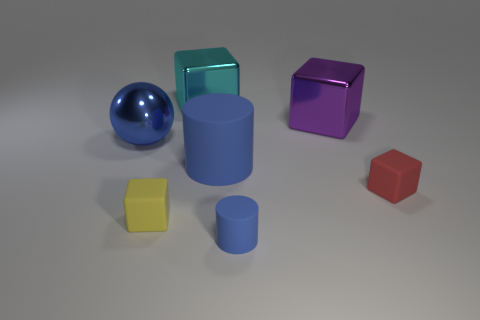How many other things are there of the same color as the big matte cylinder?
Ensure brevity in your answer.  2. Is the color of the shiny ball the same as the cylinder that is in front of the big rubber object?
Make the answer very short. Yes. What number of blue things are big shiny balls or big matte things?
Your response must be concise. 2. Are there an equal number of small blue cylinders right of the red object and tiny brown rubber cubes?
Keep it short and to the point. Yes. What color is the other small thing that is the same shape as the yellow matte thing?
Offer a very short reply. Red. How many small things have the same shape as the big matte object?
Your response must be concise. 1. There is a large sphere that is the same color as the small matte cylinder; what is its material?
Provide a succinct answer. Metal. How many tiny blue rubber cylinders are there?
Ensure brevity in your answer.  1. Are there any large yellow objects made of the same material as the large blue cylinder?
Give a very brief answer. No. What size is the other rubber cylinder that is the same color as the big rubber cylinder?
Keep it short and to the point. Small. 